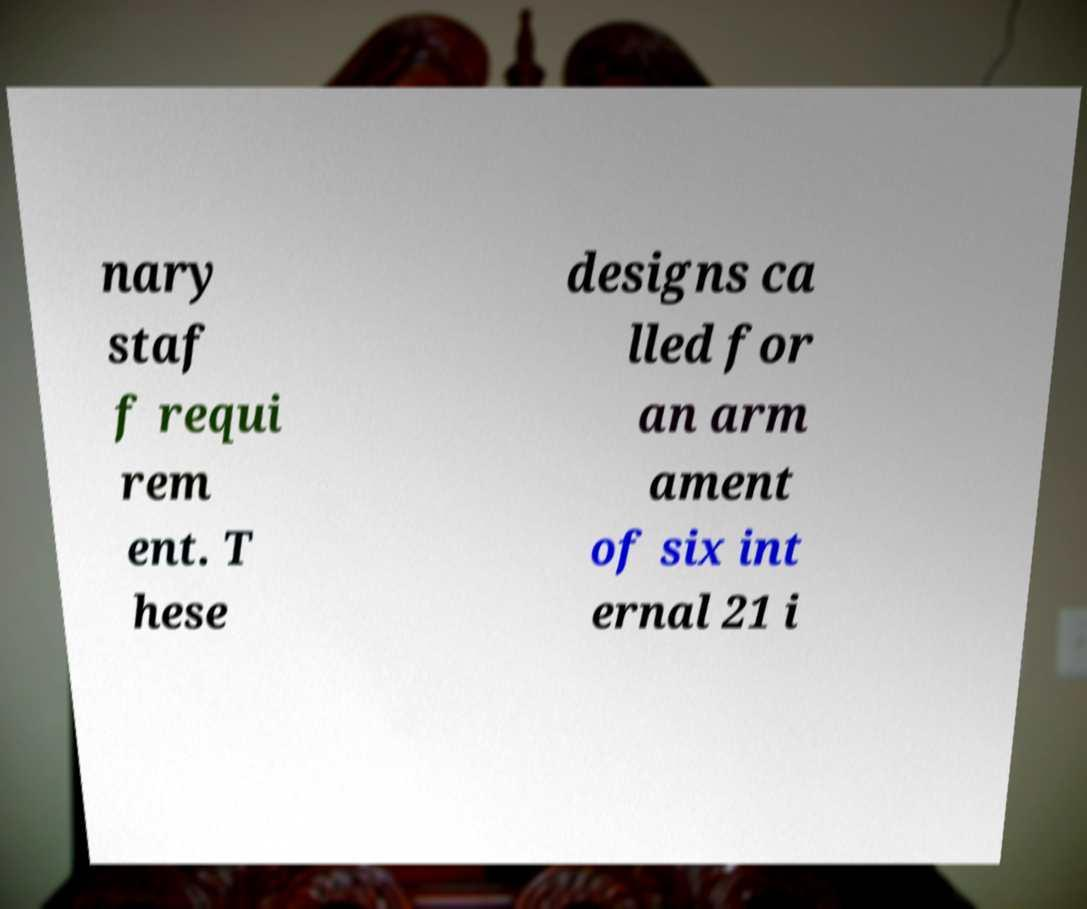Could you assist in decoding the text presented in this image and type it out clearly? nary staf f requi rem ent. T hese designs ca lled for an arm ament of six int ernal 21 i 